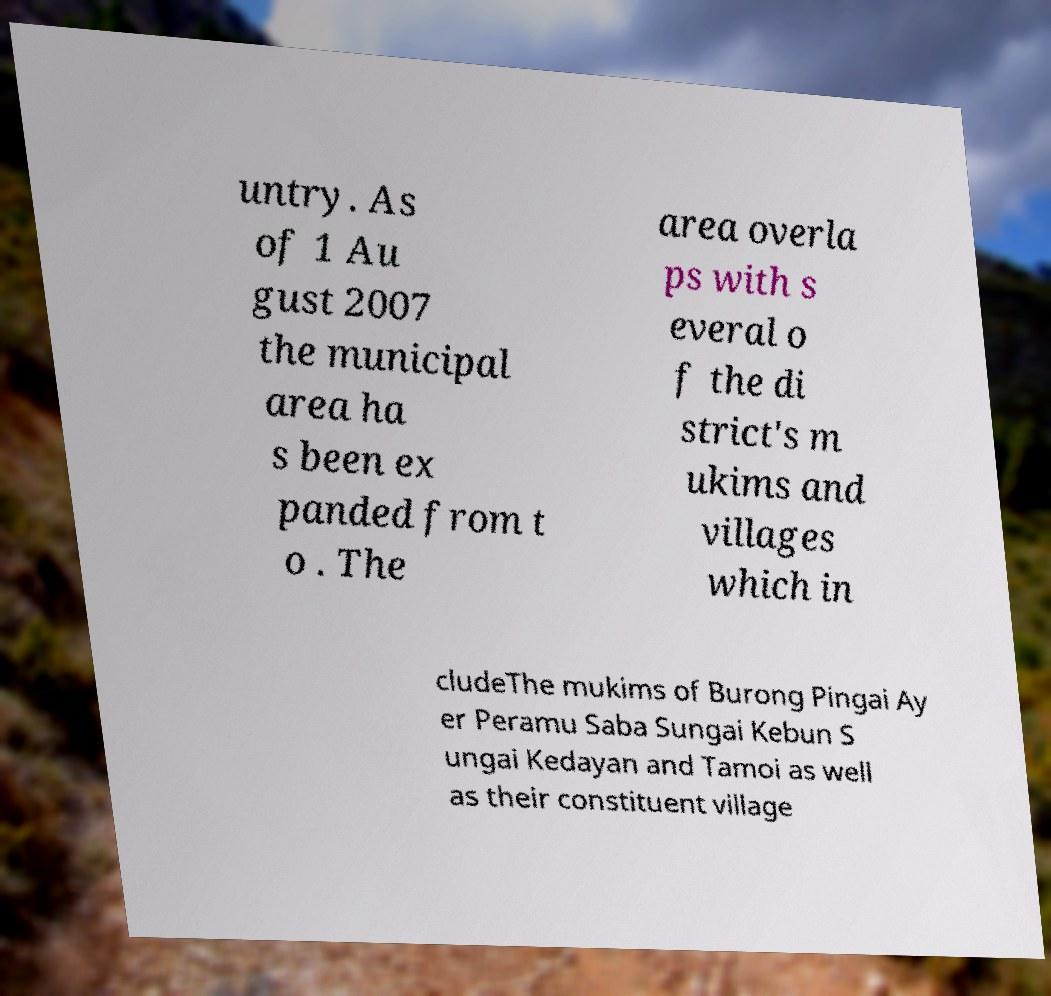Could you assist in decoding the text presented in this image and type it out clearly? untry. As of 1 Au gust 2007 the municipal area ha s been ex panded from t o . The area overla ps with s everal o f the di strict's m ukims and villages which in cludeThe mukims of Burong Pingai Ay er Peramu Saba Sungai Kebun S ungai Kedayan and Tamoi as well as their constituent village 